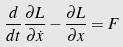Convert formula to latex. <formula><loc_0><loc_0><loc_500><loc_500>\frac { d } { d t } \frac { \partial L } { \partial \dot { x } } - \frac { \partial L } { \partial x } = F</formula> 